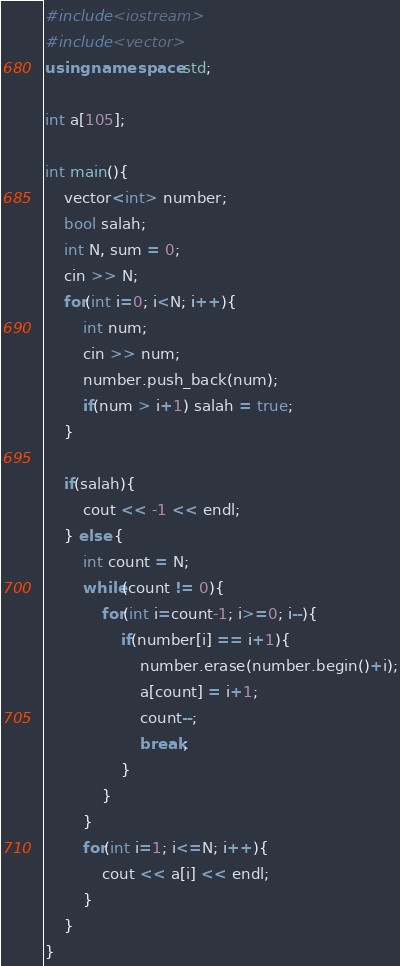Convert code to text. <code><loc_0><loc_0><loc_500><loc_500><_C++_>#include<iostream>
#include<vector>
using namespace std;

int a[105];

int main(){
    vector<int> number;
    bool salah;
    int N, sum = 0;
    cin >> N;
    for(int i=0; i<N; i++){
        int num;
        cin >> num;
        number.push_back(num);
        if(num > i+1) salah = true;
    }

    if(salah){
        cout << -1 << endl;
    } else {
        int count = N;
        while(count != 0){
            for(int i=count-1; i>=0; i--){
                if(number[i] == i+1){
                    number.erase(number.begin()+i);
                    a[count] = i+1; 
                    count--;
                    break;
                }
            }
        }
        for(int i=1; i<=N; i++){
            cout << a[i] << endl;
        }
    }
}</code> 